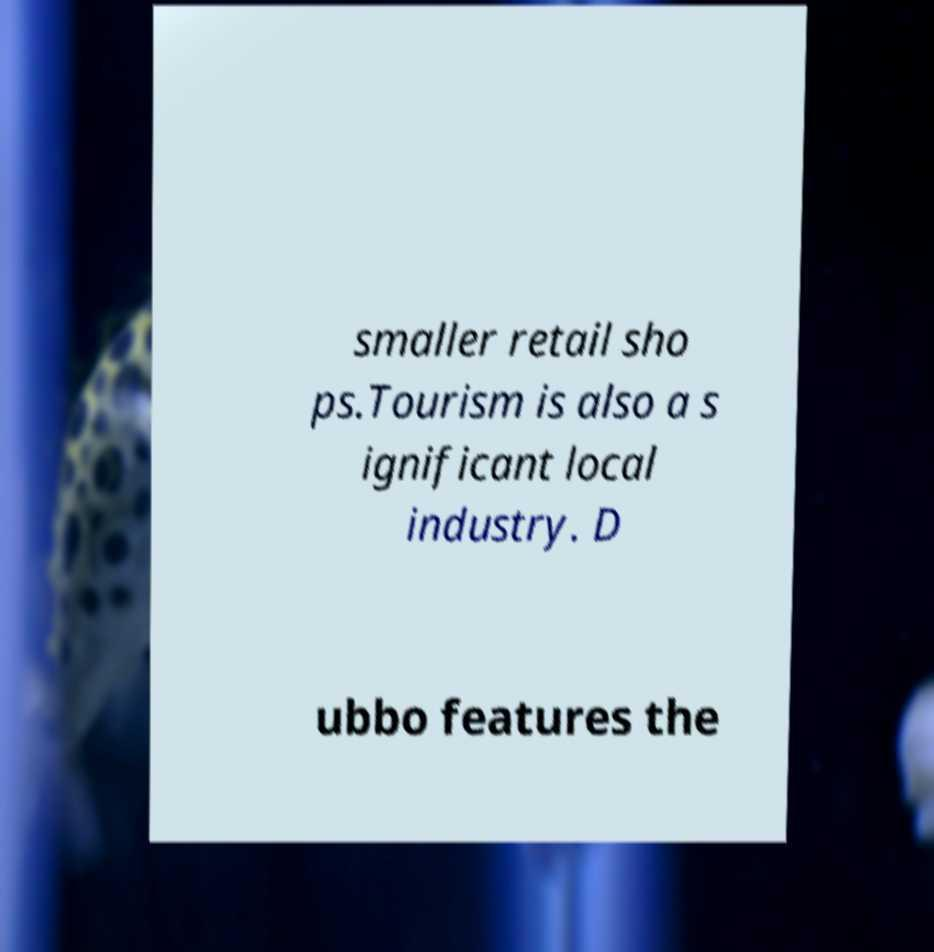Could you assist in decoding the text presented in this image and type it out clearly? smaller retail sho ps.Tourism is also a s ignificant local industry. D ubbo features the 